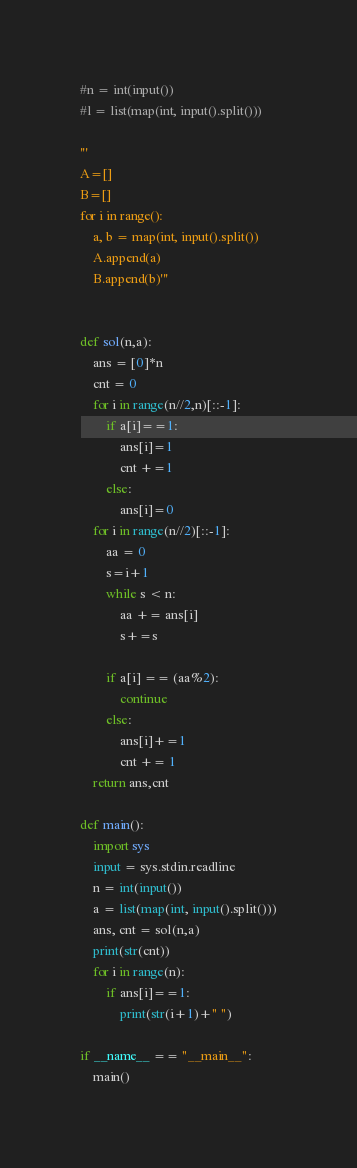Convert code to text. <code><loc_0><loc_0><loc_500><loc_500><_Python_>#n = int(input())
#l = list(map(int, input().split()))

'''
A=[]
B=[]
for i in range():
    a, b = map(int, input().split())
    A.append(a)
    B.append(b)'''


def sol(n,a):
    ans = [0]*n
    cnt = 0
    for i in range(n//2,n)[::-1]:
        if a[i]==1:
            ans[i]=1
            cnt +=1
        else:
            ans[i]=0
    for i in range(n//2)[::-1]:
        aa = 0
        s=i+1
        while s < n:
            aa += ans[i]
            s+=s

        if a[i] == (aa%2):
            continue
        else:
            ans[i]+=1
            cnt += 1
    return ans,cnt
    
def main():
    import sys
    input = sys.stdin.readline
    n = int(input())
    a = list(map(int, input().split()))
    ans, cnt = sol(n,a)
    print(str(cnt))
    for i in range(n):
        if ans[i]==1:
            print(str(i+1)+" ")

if __name__ == "__main__":
    main()
</code> 